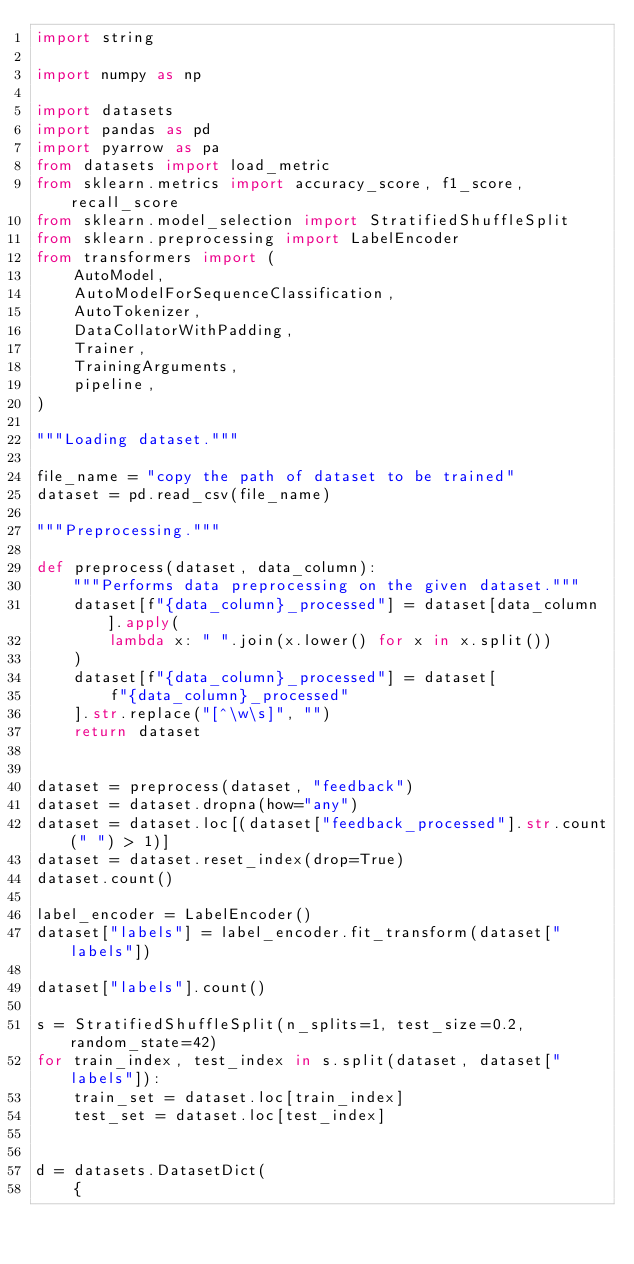<code> <loc_0><loc_0><loc_500><loc_500><_Python_>import string

import numpy as np

import datasets
import pandas as pd
import pyarrow as pa
from datasets import load_metric
from sklearn.metrics import accuracy_score, f1_score, recall_score
from sklearn.model_selection import StratifiedShuffleSplit
from sklearn.preprocessing import LabelEncoder
from transformers import (
    AutoModel,
    AutoModelForSequenceClassification,
    AutoTokenizer,
    DataCollatorWithPadding,
    Trainer,
    TrainingArguments,
    pipeline,
)

"""Loading dataset."""

file_name = "copy the path of dataset to be trained"
dataset = pd.read_csv(file_name)

"""Preprocessing."""

def preprocess(dataset, data_column):
    """Performs data preprocessing on the given dataset."""
    dataset[f"{data_column}_processed"] = dataset[data_column].apply(
        lambda x: " ".join(x.lower() for x in x.split())
    )
    dataset[f"{data_column}_processed"] = dataset[
        f"{data_column}_processed"
    ].str.replace("[^\w\s]", "")
    return dataset


dataset = preprocess(dataset, "feedback")
dataset = dataset.dropna(how="any")
dataset = dataset.loc[(dataset["feedback_processed"].str.count(" ") > 1)]
dataset = dataset.reset_index(drop=True)
dataset.count()

label_encoder = LabelEncoder()
dataset["labels"] = label_encoder.fit_transform(dataset["labels"])

dataset["labels"].count()

s = StratifiedShuffleSplit(n_splits=1, test_size=0.2, random_state=42)
for train_index, test_index in s.split(dataset, dataset["labels"]):
    train_set = dataset.loc[train_index]
    test_set = dataset.loc[test_index]


d = datasets.DatasetDict(
    {</code> 